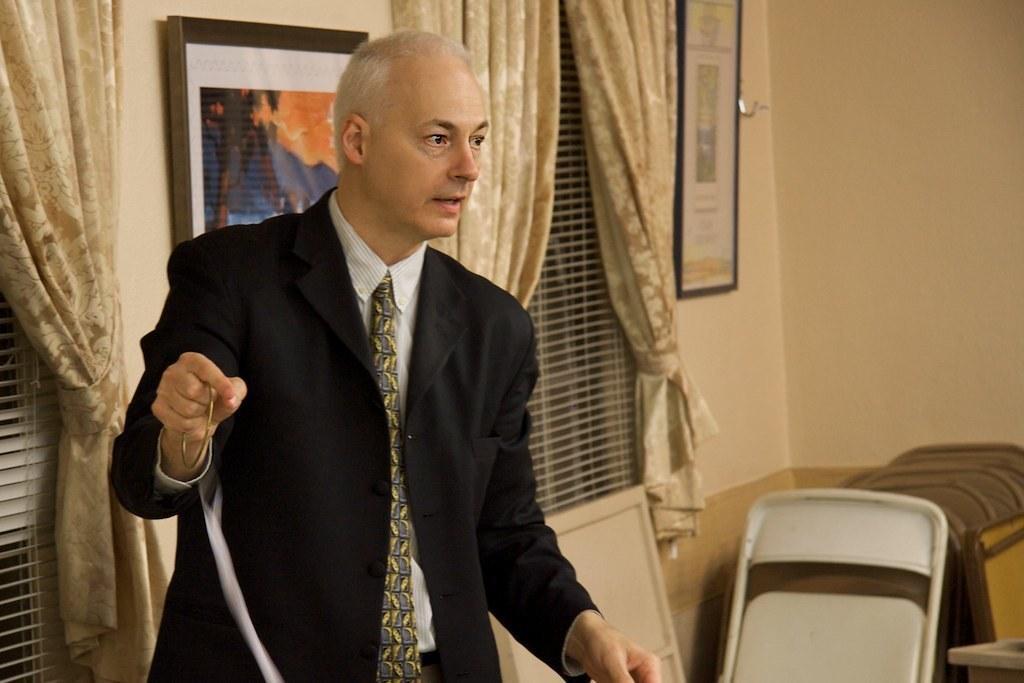Can you describe this image briefly? In this picture we can see a man wearing a blazer, tie and holding a bangle with his hand, chair, frames on the wall, windows with curtains and some objects. 